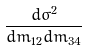Convert formula to latex. <formula><loc_0><loc_0><loc_500><loc_500>\frac { d \sigma ^ { 2 } } { d m _ { 1 2 } d m _ { 3 4 } }</formula> 